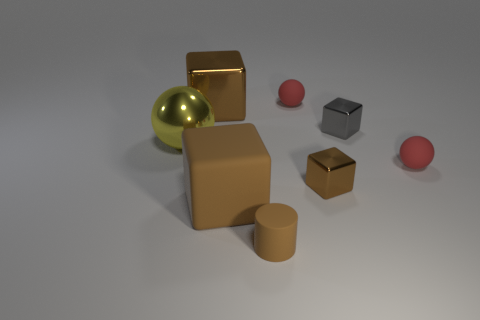Is there a matte block of the same color as the tiny rubber cylinder?
Keep it short and to the point. Yes. Do the rubber ball that is to the left of the gray object and the big yellow metallic thing have the same size?
Provide a short and direct response. No. Are there fewer large purple cylinders than large brown metal blocks?
Provide a succinct answer. Yes. Are there any objects that have the same material as the small brown cube?
Provide a succinct answer. Yes. The small rubber thing that is in front of the small brown metal cube has what shape?
Keep it short and to the point. Cylinder. There is a metal thing that is to the right of the small brown shiny thing; does it have the same color as the large rubber block?
Give a very brief answer. No. Are there fewer tiny brown cubes behind the large yellow thing than small red objects?
Give a very brief answer. Yes. What is the color of the big object that is the same material as the big yellow ball?
Provide a succinct answer. Brown. What is the size of the red rubber ball that is left of the tiny brown cube?
Offer a terse response. Small. Does the tiny brown cylinder have the same material as the large ball?
Your answer should be compact. No. 